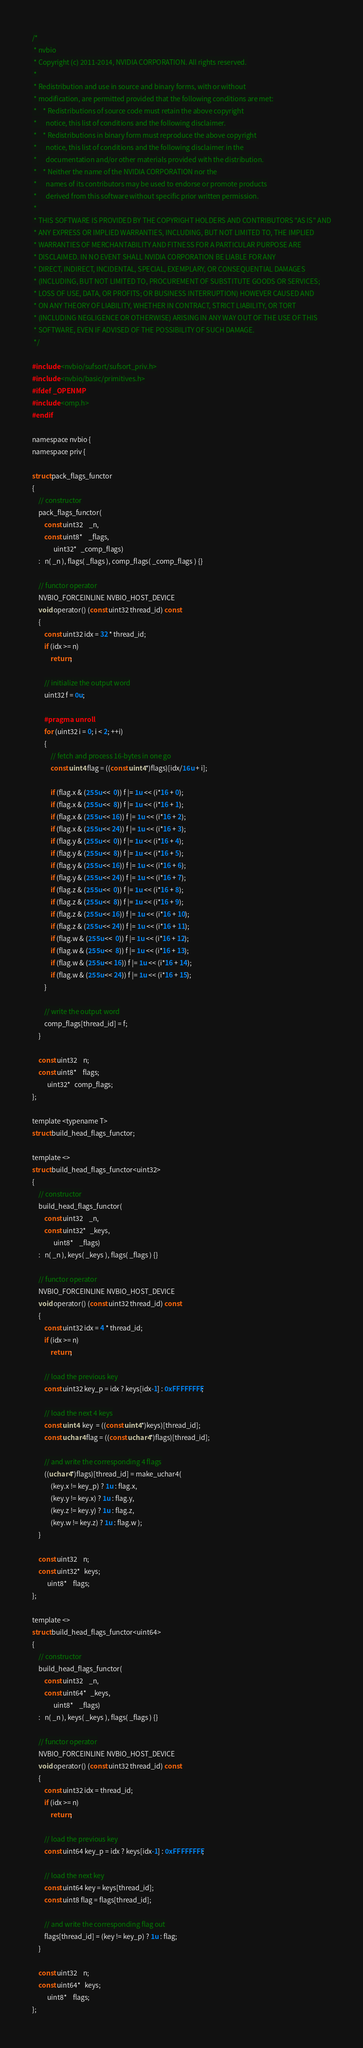<code> <loc_0><loc_0><loc_500><loc_500><_Cuda_>/*
 * nvbio
 * Copyright (c) 2011-2014, NVIDIA CORPORATION. All rights reserved.
 * 
 * Redistribution and use in source and binary forms, with or without
 * modification, are permitted provided that the following conditions are met:
 *    * Redistributions of source code must retain the above copyright
 *      notice, this list of conditions and the following disclaimer.
 *    * Redistributions in binary form must reproduce the above copyright
 *      notice, this list of conditions and the following disclaimer in the
 *      documentation and/or other materials provided with the distribution.
 *    * Neither the name of the NVIDIA CORPORATION nor the
 *      names of its contributors may be used to endorse or promote products
 *      derived from this software without specific prior written permission.
 * 
 * THIS SOFTWARE IS PROVIDED BY THE COPYRIGHT HOLDERS AND CONTRIBUTORS "AS IS" AND
 * ANY EXPRESS OR IMPLIED WARRANTIES, INCLUDING, BUT NOT LIMITED TO, THE IMPLIED
 * WARRANTIES OF MERCHANTABILITY AND FITNESS FOR A PARTICULAR PURPOSE ARE
 * DISCLAIMED. IN NO EVENT SHALL NVIDIA CORPORATION BE LIABLE FOR ANY
 * DIRECT, INDIRECT, INCIDENTAL, SPECIAL, EXEMPLARY, OR CONSEQUENTIAL DAMAGES
 * (INCLUDING, BUT NOT LIMITED TO, PROCUREMENT OF SUBSTITUTE GOODS OR SERVICES;
 * LOSS OF USE, DATA, OR PROFITS; OR BUSINESS INTERRUPTION) HOWEVER CAUSED AND
 * ON ANY THEORY OF LIABILITY, WHETHER IN CONTRACT, STRICT LIABILITY, OR TORT
 * (INCLUDING NEGLIGENCE OR OTHERWISE) ARISING IN ANY WAY OUT OF THE USE OF THIS
 * SOFTWARE, EVEN IF ADVISED OF THE POSSIBILITY OF SUCH DAMAGE.
 */

#include <nvbio/sufsort/sufsort_priv.h>
#include <nvbio/basic/primitives.h>
#ifdef _OPENMP
#include <omp.h>
#endif

namespace nvbio {
namespace priv {

struct pack_flags_functor
{
    // constructor
    pack_flags_functor(
        const uint32    _n,
        const uint8*    _flags,
              uint32*   _comp_flags)
    :   n( _n ), flags( _flags ), comp_flags( _comp_flags ) {}

    // functor operator
    NVBIO_FORCEINLINE NVBIO_HOST_DEVICE
    void operator() (const uint32 thread_id) const
    {
        const uint32 idx = 32 * thread_id;
        if (idx >= n)
            return;

        // initialize the output word
        uint32 f = 0u;

        #pragma unroll
        for (uint32 i = 0; i < 2; ++i)
        {
            // fetch and process 16-bytes in one go
            const uint4 flag = ((const uint4*)flags)[idx/16u + i];

            if (flag.x & (255u <<  0)) f |= 1u << (i*16 + 0);
            if (flag.x & (255u <<  8)) f |= 1u << (i*16 + 1);
            if (flag.x & (255u << 16)) f |= 1u << (i*16 + 2);
            if (flag.x & (255u << 24)) f |= 1u << (i*16 + 3);
            if (flag.y & (255u <<  0)) f |= 1u << (i*16 + 4);
            if (flag.y & (255u <<  8)) f |= 1u << (i*16 + 5);
            if (flag.y & (255u << 16)) f |= 1u << (i*16 + 6);
            if (flag.y & (255u << 24)) f |= 1u << (i*16 + 7);
            if (flag.z & (255u <<  0)) f |= 1u << (i*16 + 8);
            if (flag.z & (255u <<  8)) f |= 1u << (i*16 + 9);
            if (flag.z & (255u << 16)) f |= 1u << (i*16 + 10);
            if (flag.z & (255u << 24)) f |= 1u << (i*16 + 11);
            if (flag.w & (255u <<  0)) f |= 1u << (i*16 + 12);
            if (flag.w & (255u <<  8)) f |= 1u << (i*16 + 13);
            if (flag.w & (255u << 16)) f |= 1u << (i*16 + 14);
            if (flag.w & (255u << 24)) f |= 1u << (i*16 + 15);
        }

        // write the output word
        comp_flags[thread_id] = f;
    }

    const uint32    n;
    const uint8*    flags;
          uint32*   comp_flags;
};

template <typename T>
struct build_head_flags_functor;

template <>
struct build_head_flags_functor<uint32>
{
    // constructor
    build_head_flags_functor(
        const uint32    _n,
        const uint32*   _keys,
              uint8*    _flags)
    :   n( _n ), keys( _keys ), flags( _flags ) {}

    // functor operator
    NVBIO_FORCEINLINE NVBIO_HOST_DEVICE
    void operator() (const uint32 thread_id) const
    {
        const uint32 idx = 4 * thread_id;
        if (idx >= n)
            return;

        // load the previous key
        const uint32 key_p = idx ? keys[idx-1] : 0xFFFFFFFF;

        // load the next 4 keys
        const uint4  key  = ((const uint4*)keys)[thread_id];
        const uchar4 flag = ((const uchar4*)flags)[thread_id];

        // and write the corresponding 4 flags
        ((uchar4*)flags)[thread_id] = make_uchar4(
            (key.x != key_p) ? 1u : flag.x,
            (key.y != key.x) ? 1u : flag.y,
            (key.z != key.y) ? 1u : flag.z,
            (key.w != key.z) ? 1u : flag.w );
    }

    const uint32    n;
    const uint32*   keys;
          uint8*    flags;
};

template <>
struct build_head_flags_functor<uint64>
{
    // constructor
    build_head_flags_functor(
        const uint32    _n,
        const uint64*   _keys,
              uint8*    _flags)
    :   n( _n ), keys( _keys ), flags( _flags ) {}

    // functor operator
    NVBIO_FORCEINLINE NVBIO_HOST_DEVICE
    void operator() (const uint32 thread_id) const
    {
        const uint32 idx = thread_id;
        if (idx >= n)
            return;

        // load the previous key
        const uint64 key_p = idx ? keys[idx-1] : 0xFFFFFFFF;

        // load the next key
        const uint64 key = keys[thread_id];
        const uint8 flag = flags[thread_id];

        // and write the corresponding flag out
        flags[thread_id] = (key != key_p) ? 1u : flag;
    }

    const uint32    n;
    const uint64*   keys;
          uint8*    flags;
};
</code> 